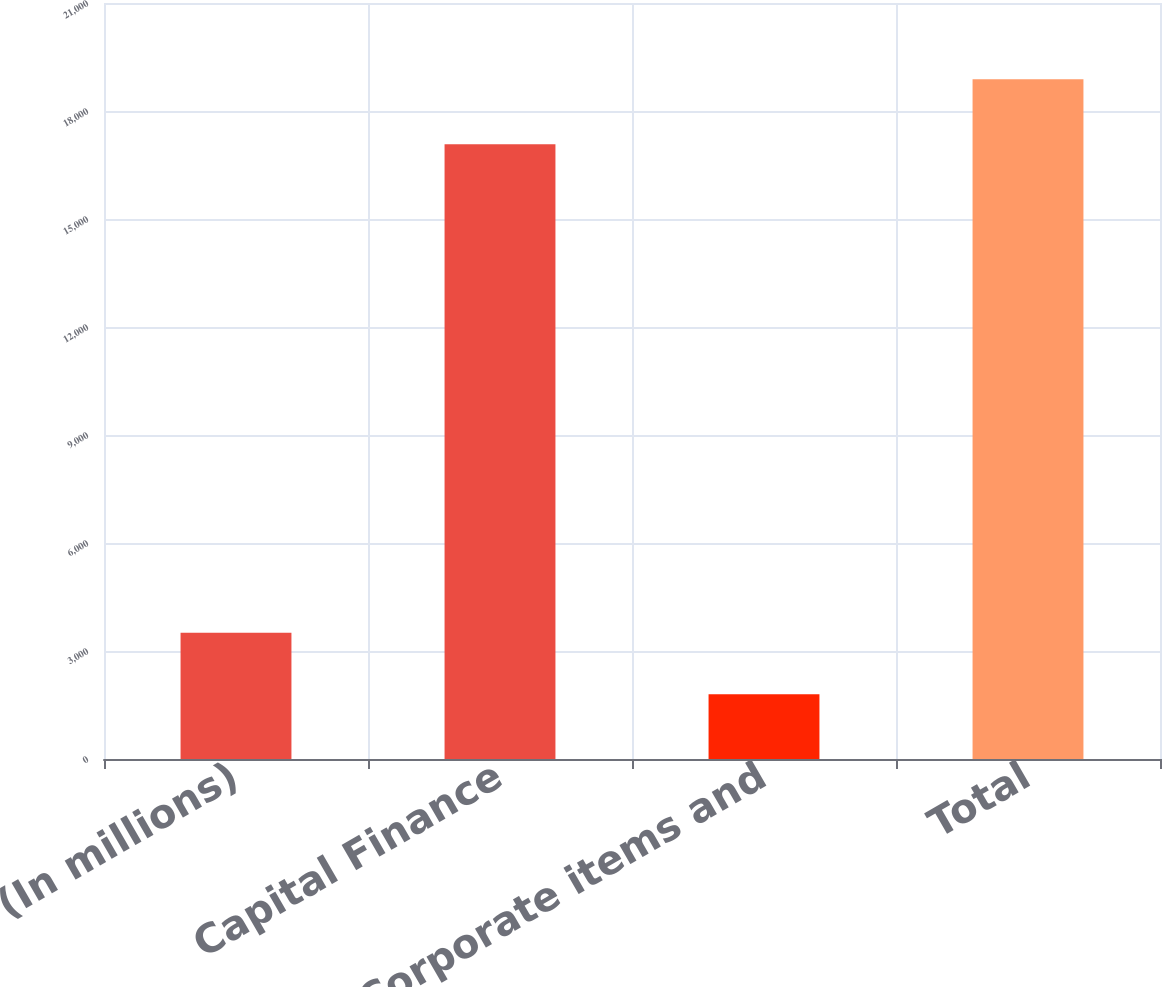<chart> <loc_0><loc_0><loc_500><loc_500><bar_chart><fcel>(In millions)<fcel>Capital Finance<fcel>Corporate items and<fcel>Total<nl><fcel>3507.9<fcel>17079<fcel>1800<fcel>18879<nl></chart> 